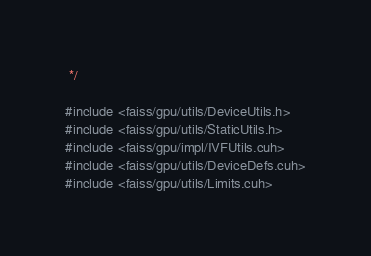<code> <loc_0><loc_0><loc_500><loc_500><_Cuda_> */

#include <faiss/gpu/utils/DeviceUtils.h>
#include <faiss/gpu/utils/StaticUtils.h>
#include <faiss/gpu/impl/IVFUtils.cuh>
#include <faiss/gpu/utils/DeviceDefs.cuh>
#include <faiss/gpu/utils/Limits.cuh></code> 